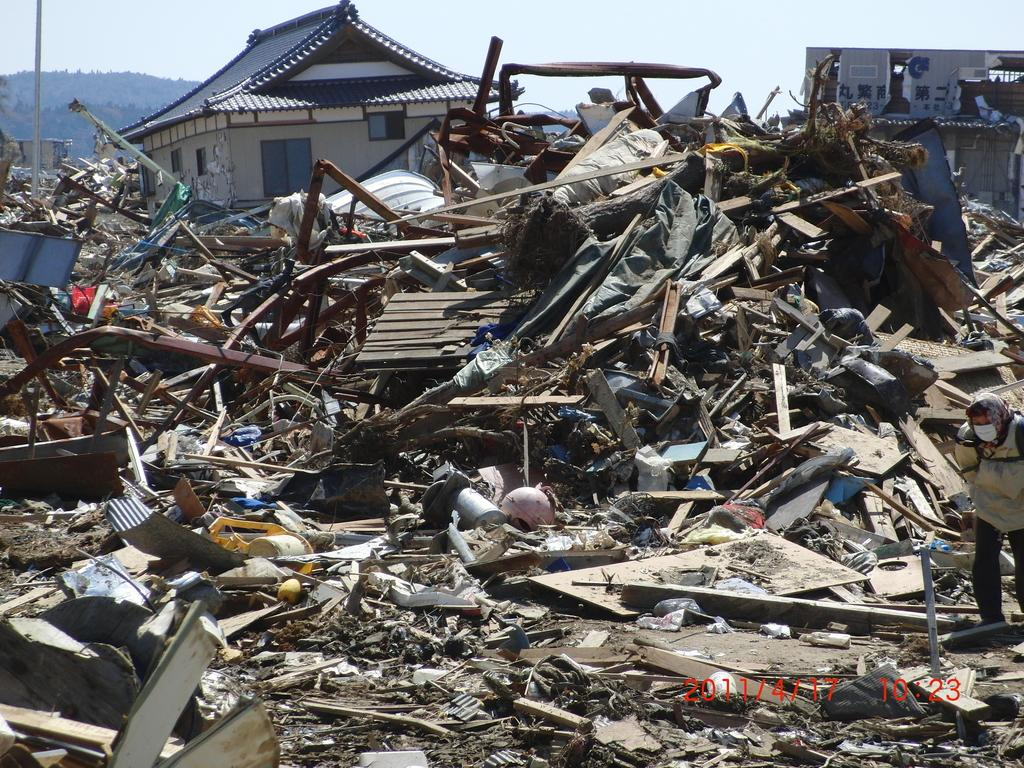What is the main subject of the image? There is a person standing in the image. What else can be seen in the image besides the person? There are scrap items and a house in the image. What is visible in the background of the image? The sky is visible in the background of the image. What type of wrist accessory is the person wearing in the image? There is no wrist accessory visible on the person in the image. What offer is being made by the person in the image? There is no offer being made by the person in the image; they are simply standing. 